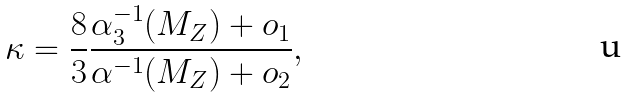Convert formula to latex. <formula><loc_0><loc_0><loc_500><loc_500>\kappa = \frac { 8 } { 3 } \frac { \alpha _ { 3 } ^ { - 1 } ( M _ { Z } ) + o _ { 1 } } { \alpha ^ { - 1 } ( M _ { Z } ) + o _ { 2 } } ,</formula> 